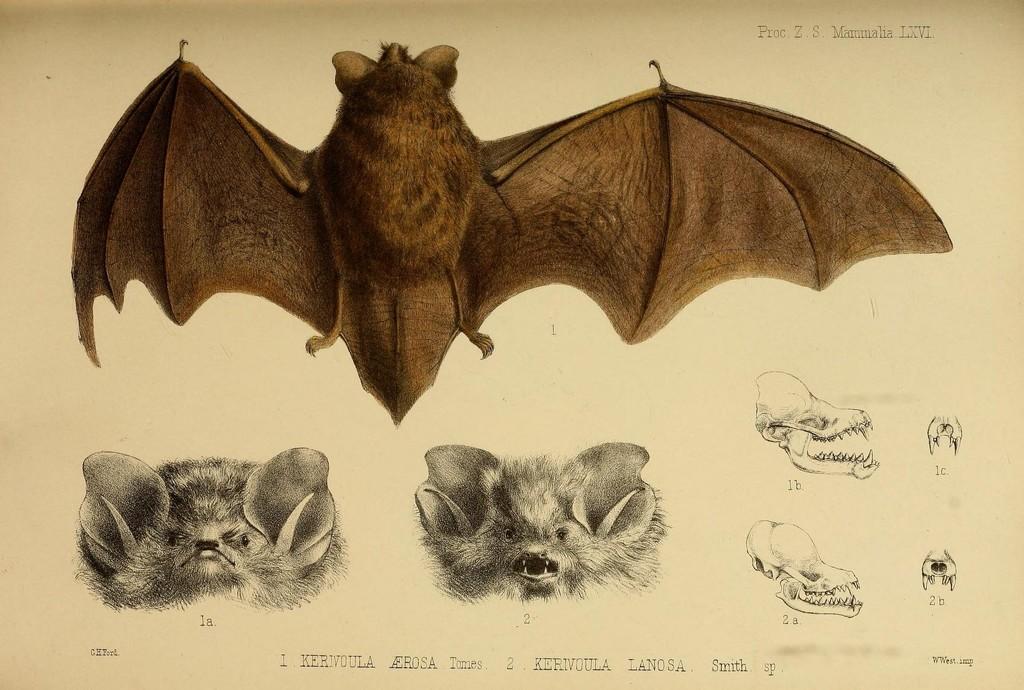Could you give a brief overview of what you see in this image? The image looks like a paper, on the paper we can see drawings of bats and their claws and skull. At the bottom there is text. 